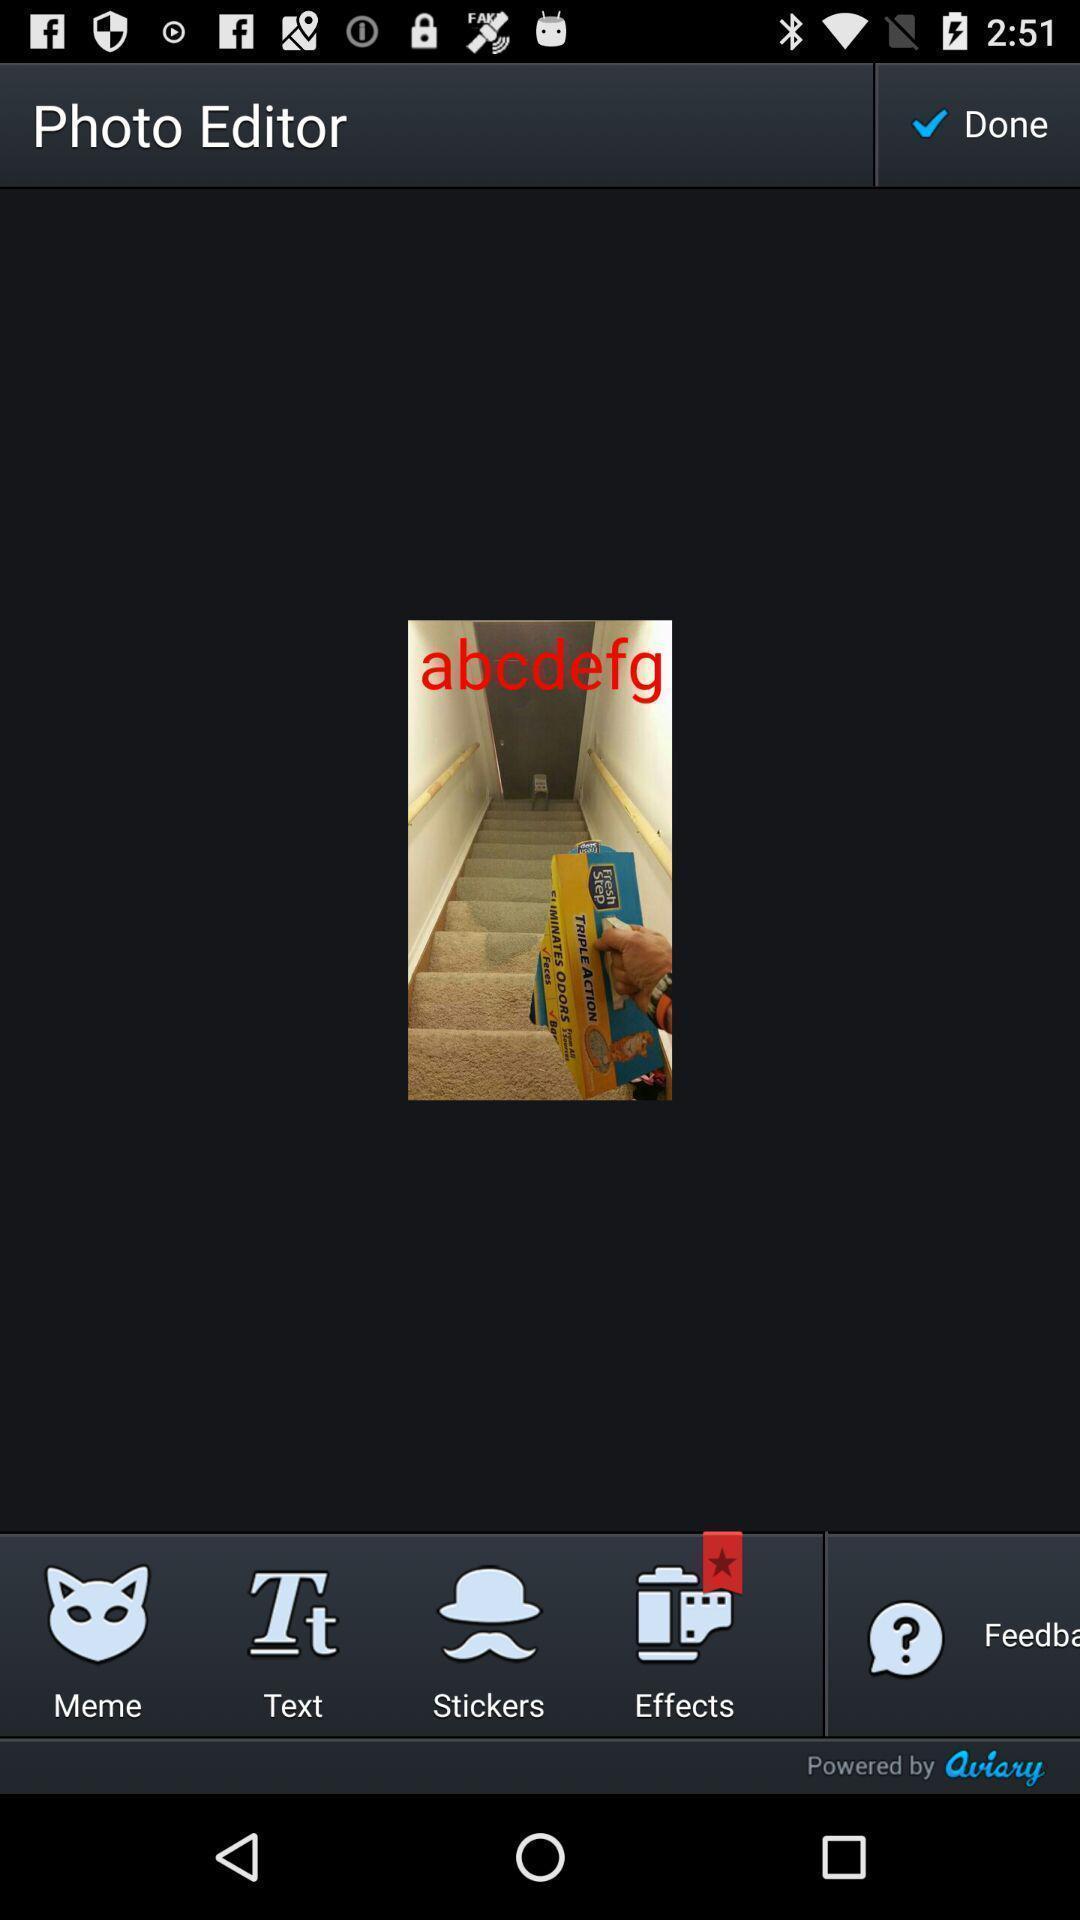Summarize the information in this screenshot. Screen shows edit options for photo editor app. 